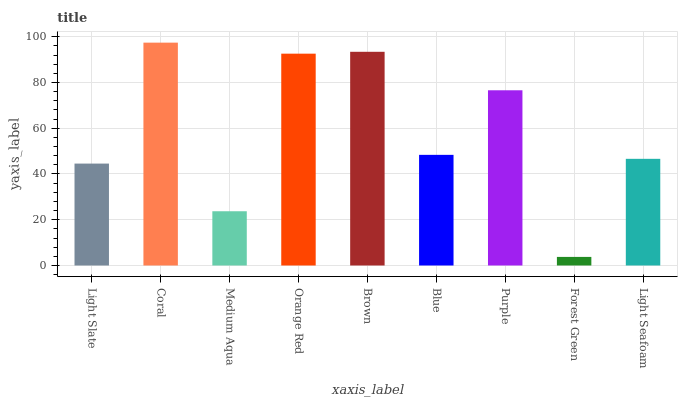Is Forest Green the minimum?
Answer yes or no. Yes. Is Coral the maximum?
Answer yes or no. Yes. Is Medium Aqua the minimum?
Answer yes or no. No. Is Medium Aqua the maximum?
Answer yes or no. No. Is Coral greater than Medium Aqua?
Answer yes or no. Yes. Is Medium Aqua less than Coral?
Answer yes or no. Yes. Is Medium Aqua greater than Coral?
Answer yes or no. No. Is Coral less than Medium Aqua?
Answer yes or no. No. Is Blue the high median?
Answer yes or no. Yes. Is Blue the low median?
Answer yes or no. Yes. Is Light Slate the high median?
Answer yes or no. No. Is Coral the low median?
Answer yes or no. No. 